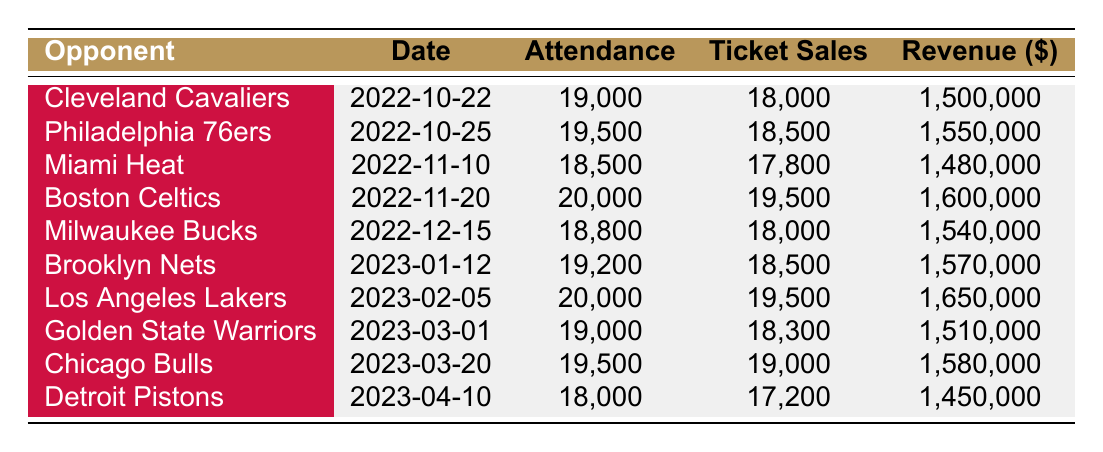What was the attendance for the game against the Boston Celtics? The attendance for the game on November 20, 2022, against the Boston Celtics is listed directly in the table as 20,000.
Answer: 20,000 Which game had the highest ticket sales? The table shows that the highest ticket sales occurred during the game against the Boston Celtics on November 20, 2022, with 19,500 tickets sold.
Answer: 19,500 What is the difference in attendance between the game against the Miami Heat and the game against the Detroit Pistons? The attendance for the Miami Heat game is 18,500, and for the Detroit Pistons game, it is 18,000. The difference is 18,500 - 18,000 = 500.
Answer: 500 Was the revenue for the Los Angeles Lakers game more than that for the Brooklyn Nets game? The revenue for the Los Angeles Lakers game is listed as 1,650,000, and for the Brooklyn Nets game, it is 1,570,000. Since 1,650,000 is greater than 1,570,000, the answer is yes.
Answer: Yes What is the average revenue from all home games? To find the average revenue, sum up all the revenues: 1,500,000 + 1,550,000 + 1,480,000 + 1,600,000 + 1,540,000 + 1,570,000 + 1,650,000 + 1,510,000 + 1,580,000 + 1,450,000 = 15,530,000. Then divide by the number of games, which is 10: 15,530,000 / 10 = 1,553,000.
Answer: 1,553,000 Which opponent had a higher attendance, the Cleveland Cavaliers or the Miami Heat? The attendance for the Cleveland Cavaliers game is 19,000, while for the Miami Heat it is 18,500. Comparing these two numbers, 19,000 is greater than 18,500, so the Cavaliers had a higher attendance.
Answer: Cleveland Cavaliers How many home games had attendance greater than 19,000? By looking at the attendance figures in the table, the games against the Boston Celtics, Los Angeles Lakers, and Cleveland Cavaliers had attendance greater than 19,000, totaling three games.
Answer: 3 What was the total revenue generated from the games played in December? The revenue from the game against the Milwaukee Bucks on December 15, 2022 is 1,540,000. Since this is the only December game listed, the total revenue generated is just this amount.
Answer: 1,540,000 Did ticket sales ever exceed attendance? By examining the table, we see that ticket sales never exceed attendance in any game, as the ticket sales values are always less than or equal to attendance. Therefore, the answer is no.
Answer: No 